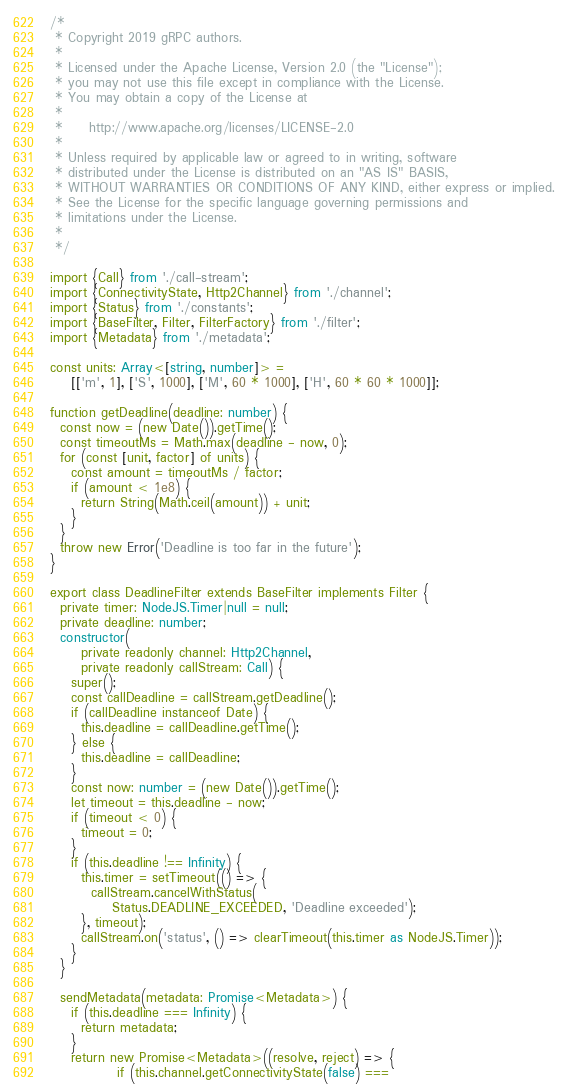<code> <loc_0><loc_0><loc_500><loc_500><_TypeScript_>/*
 * Copyright 2019 gRPC authors.
 *
 * Licensed under the Apache License, Version 2.0 (the "License");
 * you may not use this file except in compliance with the License.
 * You may obtain a copy of the License at
 *
 *     http://www.apache.org/licenses/LICENSE-2.0
 *
 * Unless required by applicable law or agreed to in writing, software
 * distributed under the License is distributed on an "AS IS" BASIS,
 * WITHOUT WARRANTIES OR CONDITIONS OF ANY KIND, either express or implied.
 * See the License for the specific language governing permissions and
 * limitations under the License.
 *
 */

import {Call} from './call-stream';
import {ConnectivityState, Http2Channel} from './channel';
import {Status} from './constants';
import {BaseFilter, Filter, FilterFactory} from './filter';
import {Metadata} from './metadata';

const units: Array<[string, number]> =
    [['m', 1], ['S', 1000], ['M', 60 * 1000], ['H', 60 * 60 * 1000]];

function getDeadline(deadline: number) {
  const now = (new Date()).getTime();
  const timeoutMs = Math.max(deadline - now, 0);
  for (const [unit, factor] of units) {
    const amount = timeoutMs / factor;
    if (amount < 1e8) {
      return String(Math.ceil(amount)) + unit;
    }
  }
  throw new Error('Deadline is too far in the future');
}

export class DeadlineFilter extends BaseFilter implements Filter {
  private timer: NodeJS.Timer|null = null;
  private deadline: number;
  constructor(
      private readonly channel: Http2Channel,
      private readonly callStream: Call) {
    super();
    const callDeadline = callStream.getDeadline();
    if (callDeadline instanceof Date) {
      this.deadline = callDeadline.getTime();
    } else {
      this.deadline = callDeadline;
    }
    const now: number = (new Date()).getTime();
    let timeout = this.deadline - now;
    if (timeout < 0) {
      timeout = 0;
    }
    if (this.deadline !== Infinity) {
      this.timer = setTimeout(() => {
        callStream.cancelWithStatus(
            Status.DEADLINE_EXCEEDED, 'Deadline exceeded');
      }, timeout);
      callStream.on('status', () => clearTimeout(this.timer as NodeJS.Timer));
    }
  }

  sendMetadata(metadata: Promise<Metadata>) {
    if (this.deadline === Infinity) {
      return metadata;
    }
    return new Promise<Metadata>((resolve, reject) => {
             if (this.channel.getConnectivityState(false) ===</code> 